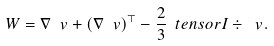Convert formula to latex. <formula><loc_0><loc_0><loc_500><loc_500>\ W = \nabla \ v + ( \nabla \ v ) ^ { \top } - \frac { 2 } { 3 } \ t e n s o r { I } \div { \ v } .</formula> 